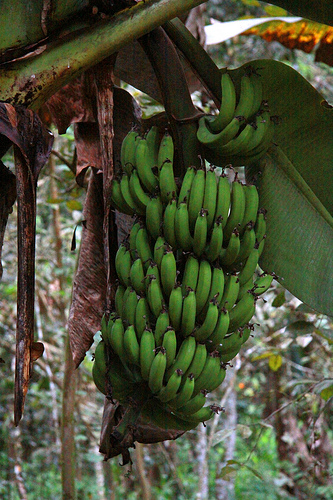If the bananas could talk, what would they say about their daily experiences? The bananas would likely express contentment with their daily routine, finding joy in the sunshine and the refreshing rain that keeps them growing strong. They might share stories of the passing animals and insects, treating them as old acquaintances. They would probably express a sense of community, being tightly packed together and supporting each other as they grow. There might be concerns about eventually leaving the bunch when harvest time comes, feeling both anticipation and a bit of sadness for the departure from their familiar surroundings. 